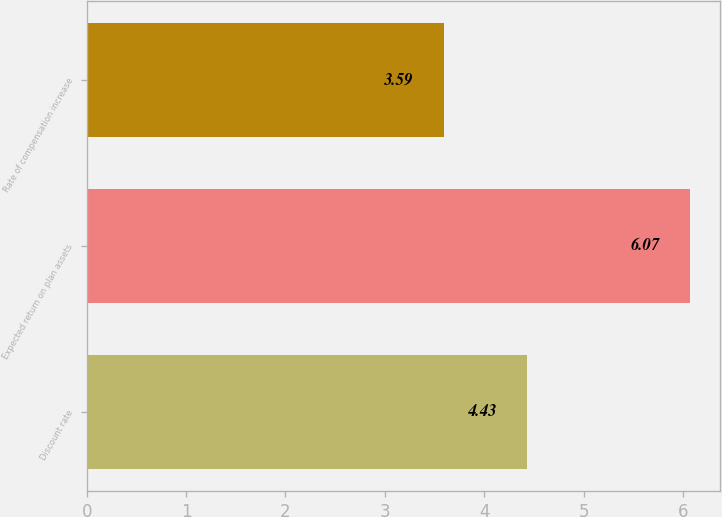Convert chart to OTSL. <chart><loc_0><loc_0><loc_500><loc_500><bar_chart><fcel>Discount rate<fcel>Expected return on plan assets<fcel>Rate of compensation increase<nl><fcel>4.43<fcel>6.07<fcel>3.59<nl></chart> 